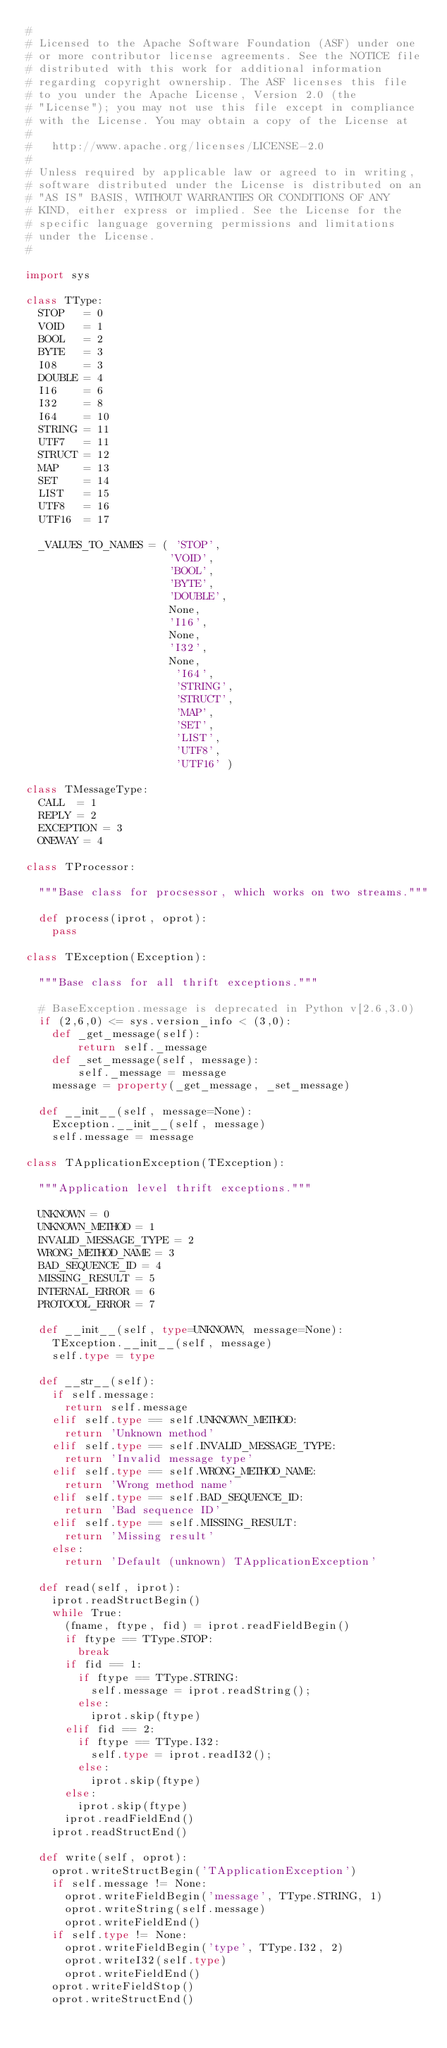Convert code to text. <code><loc_0><loc_0><loc_500><loc_500><_Python_>#
# Licensed to the Apache Software Foundation (ASF) under one
# or more contributor license agreements. See the NOTICE file
# distributed with this work for additional information
# regarding copyright ownership. The ASF licenses this file
# to you under the Apache License, Version 2.0 (the
# "License"); you may not use this file except in compliance
# with the License. You may obtain a copy of the License at
#
#   http://www.apache.org/licenses/LICENSE-2.0
#
# Unless required by applicable law or agreed to in writing,
# software distributed under the License is distributed on an
# "AS IS" BASIS, WITHOUT WARRANTIES OR CONDITIONS OF ANY
# KIND, either express or implied. See the License for the
# specific language governing permissions and limitations
# under the License.
#

import sys

class TType:
  STOP   = 0
  VOID   = 1
  BOOL   = 2
  BYTE   = 3
  I08    = 3
  DOUBLE = 4
  I16    = 6
  I32    = 8
  I64    = 10
  STRING = 11
  UTF7   = 11
  STRUCT = 12
  MAP    = 13
  SET    = 14
  LIST   = 15
  UTF8   = 16
  UTF16  = 17

  _VALUES_TO_NAMES = ( 'STOP',
                      'VOID',
                      'BOOL',
                      'BYTE',
                      'DOUBLE',
                      None,
                      'I16',
                      None,
                      'I32',
                      None,
                       'I64',
                       'STRING',
                       'STRUCT',
                       'MAP',
                       'SET',
                       'LIST',
                       'UTF8',
                       'UTF16' )

class TMessageType:
  CALL  = 1
  REPLY = 2
  EXCEPTION = 3
  ONEWAY = 4

class TProcessor:

  """Base class for procsessor, which works on two streams."""

  def process(iprot, oprot):
    pass

class TException(Exception):

  """Base class for all thrift exceptions."""

  # BaseException.message is deprecated in Python v[2.6,3.0)
  if (2,6,0) <= sys.version_info < (3,0):
    def _get_message(self):
	    return self._message
    def _set_message(self, message):
	    self._message = message
    message = property(_get_message, _set_message)

  def __init__(self, message=None):
    Exception.__init__(self, message)
    self.message = message

class TApplicationException(TException):

  """Application level thrift exceptions."""

  UNKNOWN = 0
  UNKNOWN_METHOD = 1
  INVALID_MESSAGE_TYPE = 2
  WRONG_METHOD_NAME = 3
  BAD_SEQUENCE_ID = 4
  MISSING_RESULT = 5
  INTERNAL_ERROR = 6
  PROTOCOL_ERROR = 7

  def __init__(self, type=UNKNOWN, message=None):
    TException.__init__(self, message)
    self.type = type

  def __str__(self):
    if self.message:
      return self.message
    elif self.type == self.UNKNOWN_METHOD:
      return 'Unknown method'
    elif self.type == self.INVALID_MESSAGE_TYPE:
      return 'Invalid message type'
    elif self.type == self.WRONG_METHOD_NAME:
      return 'Wrong method name'
    elif self.type == self.BAD_SEQUENCE_ID:
      return 'Bad sequence ID'
    elif self.type == self.MISSING_RESULT:
      return 'Missing result'
    else:
      return 'Default (unknown) TApplicationException'

  def read(self, iprot):
    iprot.readStructBegin()
    while True:
      (fname, ftype, fid) = iprot.readFieldBegin()
      if ftype == TType.STOP:
        break
      if fid == 1:
        if ftype == TType.STRING:
          self.message = iprot.readString();
        else:
          iprot.skip(ftype)
      elif fid == 2:
        if ftype == TType.I32:
          self.type = iprot.readI32();
        else:
          iprot.skip(ftype)
      else:
        iprot.skip(ftype)
      iprot.readFieldEnd()
    iprot.readStructEnd()

  def write(self, oprot):
    oprot.writeStructBegin('TApplicationException')
    if self.message != None:
      oprot.writeFieldBegin('message', TType.STRING, 1)
      oprot.writeString(self.message)
      oprot.writeFieldEnd()
    if self.type != None:
      oprot.writeFieldBegin('type', TType.I32, 2)
      oprot.writeI32(self.type)
      oprot.writeFieldEnd()
    oprot.writeFieldStop()
    oprot.writeStructEnd()
</code> 